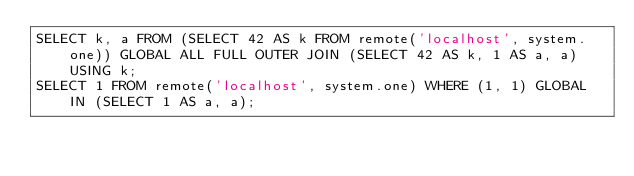<code> <loc_0><loc_0><loc_500><loc_500><_SQL_>SELECT k, a FROM (SELECT 42 AS k FROM remote('localhost', system.one)) GLOBAL ALL FULL OUTER JOIN (SELECT 42 AS k, 1 AS a, a) USING k;
SELECT 1 FROM remote('localhost', system.one) WHERE (1, 1) GLOBAL IN (SELECT 1 AS a, a);
</code> 